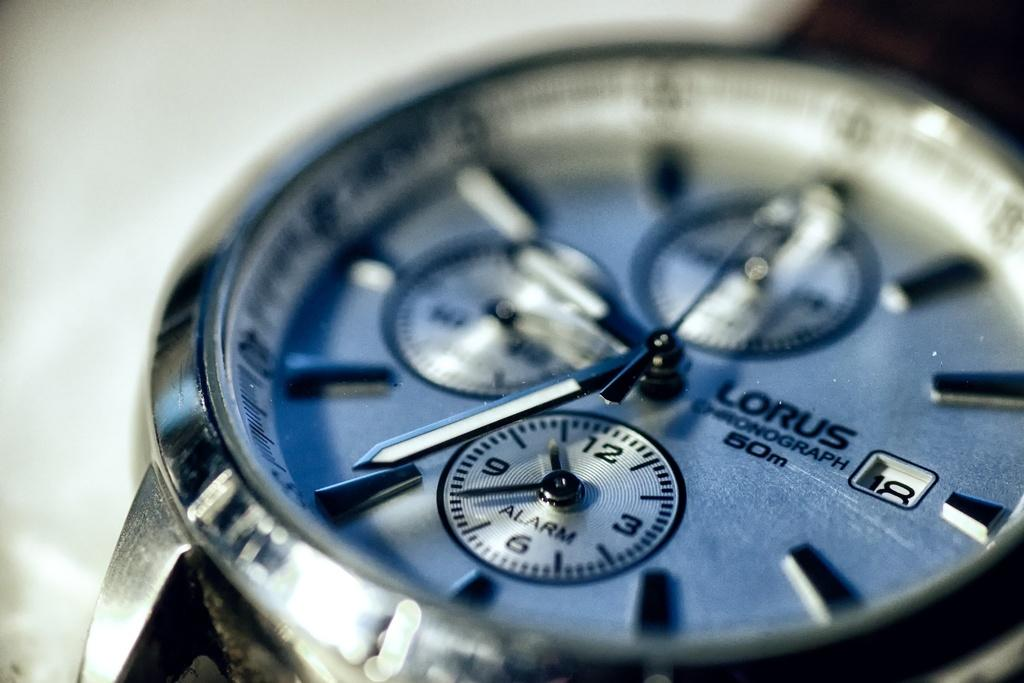<image>
Offer a succinct explanation of the picture presented. Baby blue face of a Lorus watch which has the time at 7. 